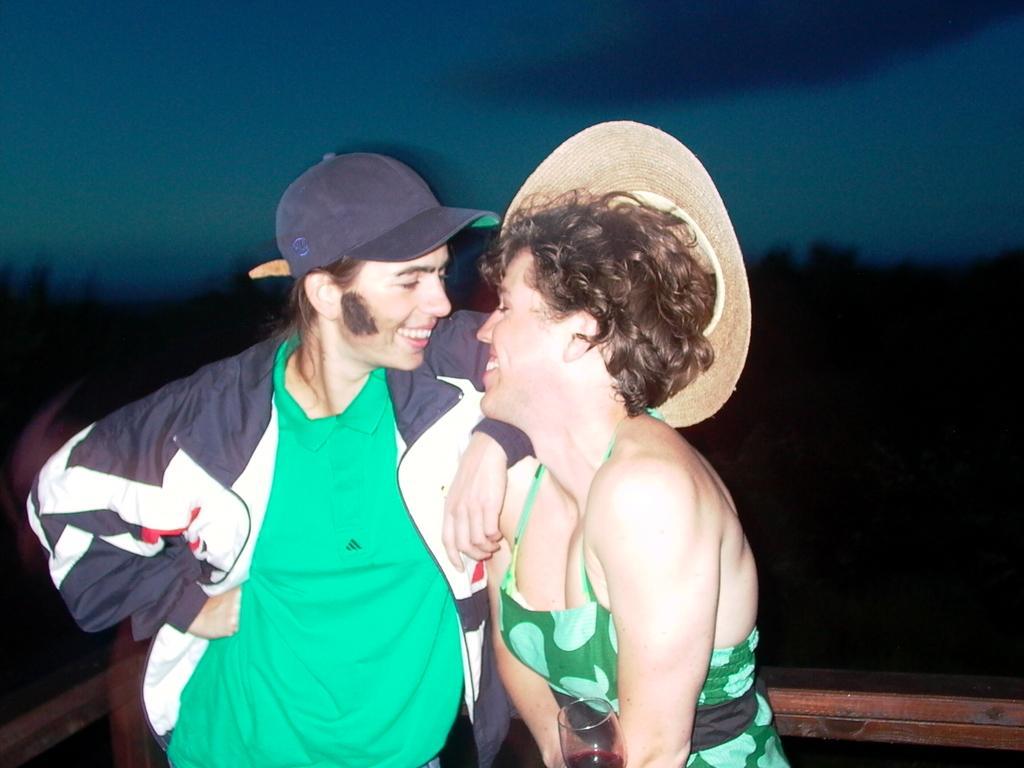How would you summarize this image in a sentence or two? In this image I can see in the middle a girl is smiling, she is wearing a green color dress and a hat. Beside her there is another person smiling and also wearing the cap. At the top it looks like the sky. 